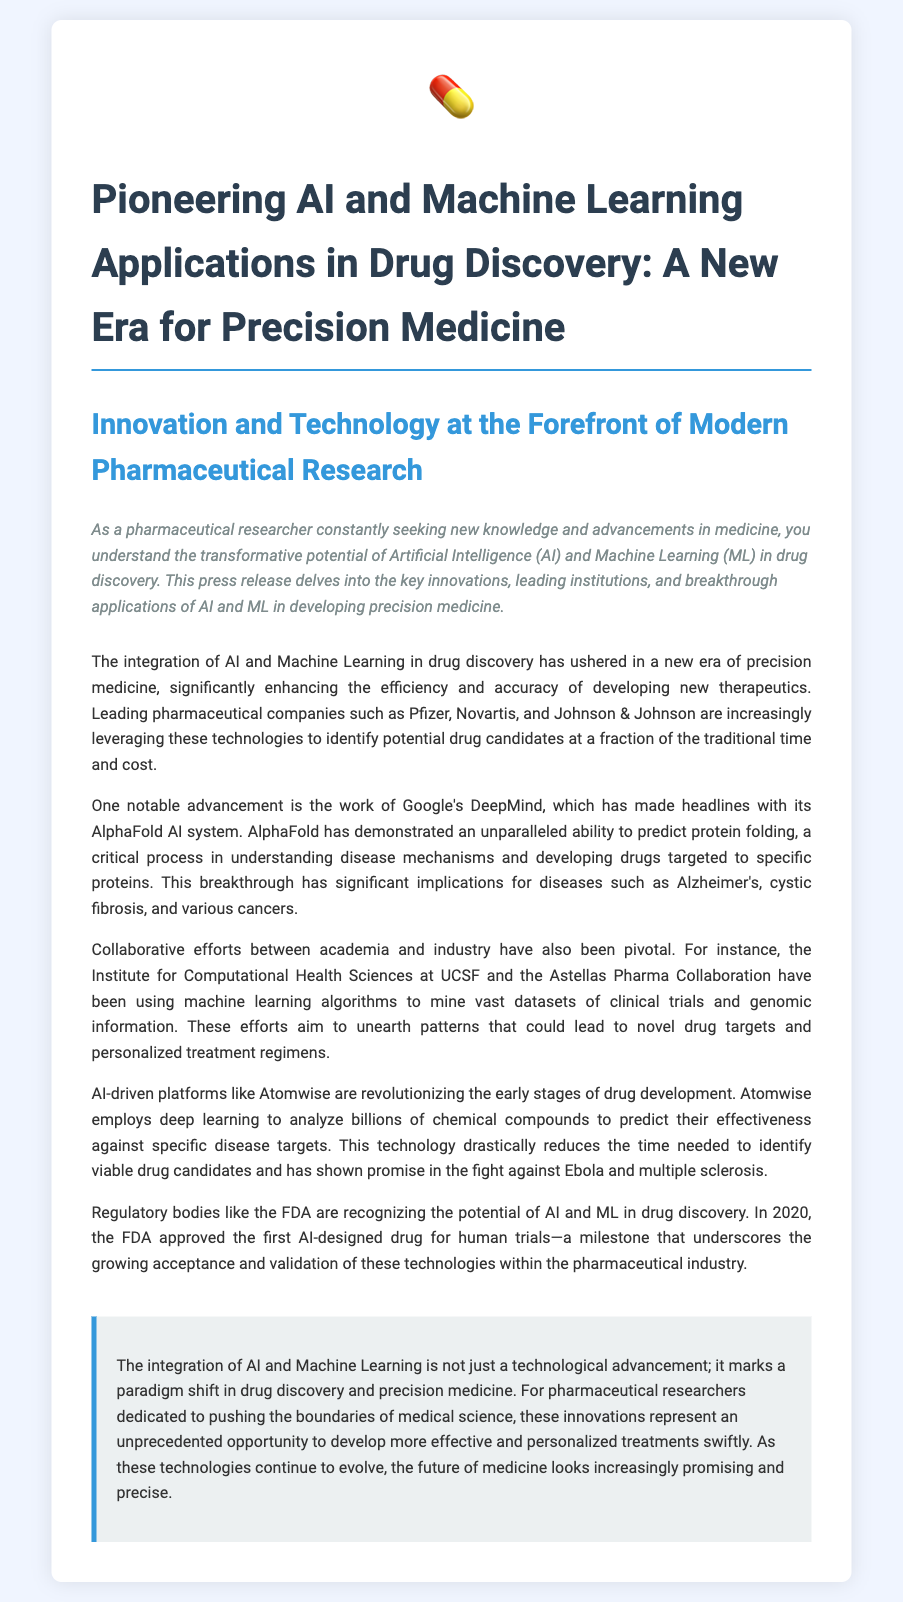What is the title of the press release? The title is mentioned at the beginning of the document and highlights the main focus of the content.
Answer: Pioneering AI and Machine Learning Applications in Drug Discovery: A New Era for Precision Medicine Which companies are mentioned as leading pharmaceutical companies? The document lists specific companies that are leveraging AI and ML in drug discovery.
Answer: Pfizer, Novartis, Johnson & Johnson What breakthrough technology is developed by Google's DeepMind? The text highlights a notable advancement in AI by a specific organization within the document.
Answer: AlphaFold In what year did the FDA approve the first AI-designed drug for human trials? The document specifies an important milestone related to regulatory acceptance of AI in drug discovery.
Answer: 2020 What is the name of the platform that uses deep learning to analyze chemical compounds? This question asks for the name of an AI-driven platform mentioned in the document that contributes to drug development.
Answer: Atomwise How many diseases are mentioned in connection with Google's AlphaFold? The document provides an overview of diseases associated with a specific technological advancement.
Answer: Three 